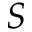Convert formula to latex. <formula><loc_0><loc_0><loc_500><loc_500>S</formula> 